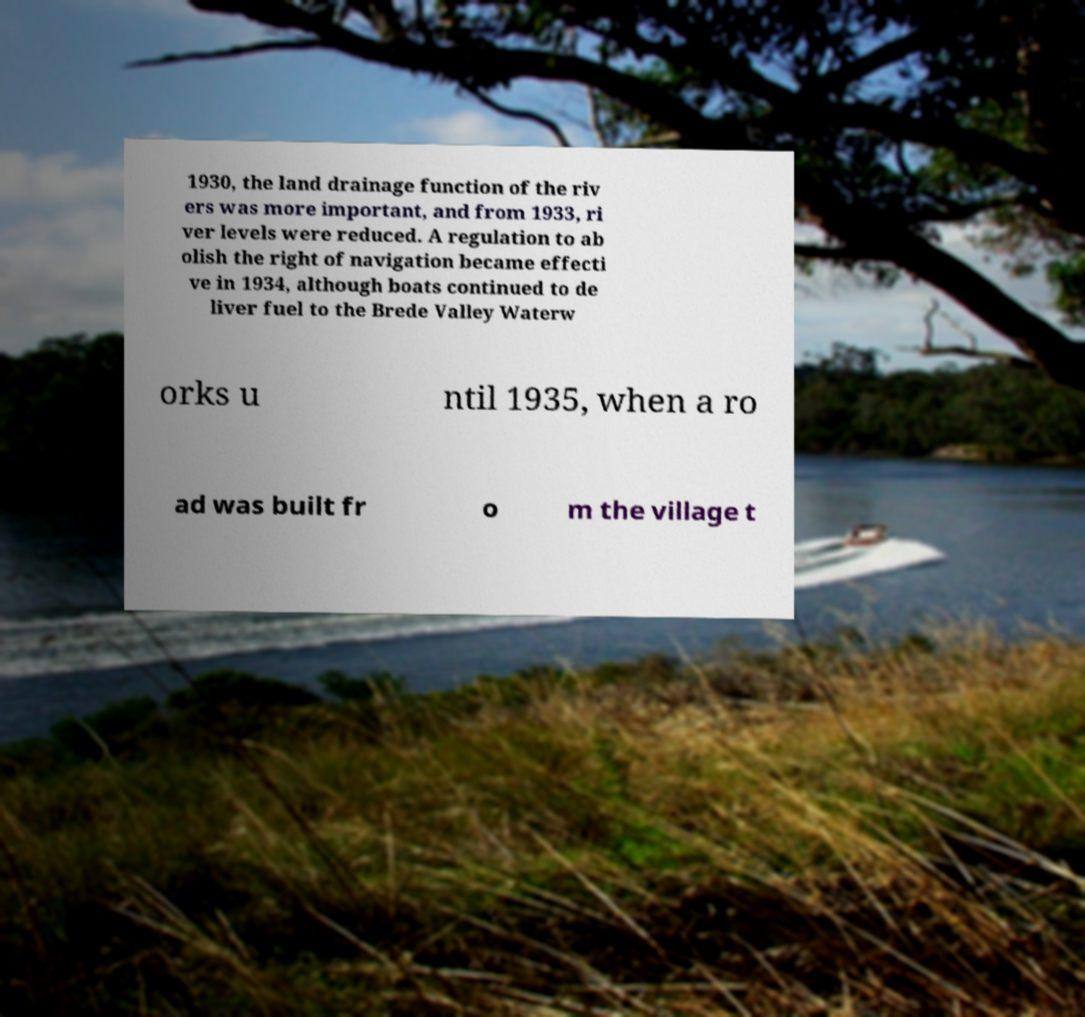Can you accurately transcribe the text from the provided image for me? 1930, the land drainage function of the riv ers was more important, and from 1933, ri ver levels were reduced. A regulation to ab olish the right of navigation became effecti ve in 1934, although boats continued to de liver fuel to the Brede Valley Waterw orks u ntil 1935, when a ro ad was built fr o m the village t 